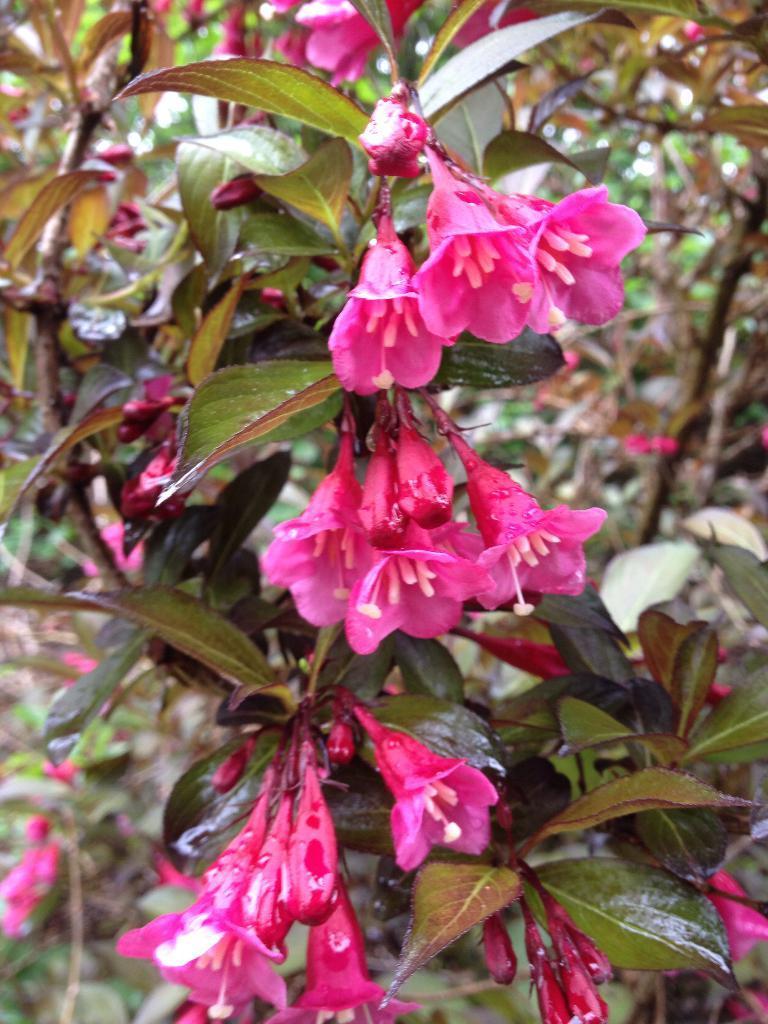Can you describe this image briefly? In this image we can see stems with leaves, flowers and buds. In the background it is blur. 